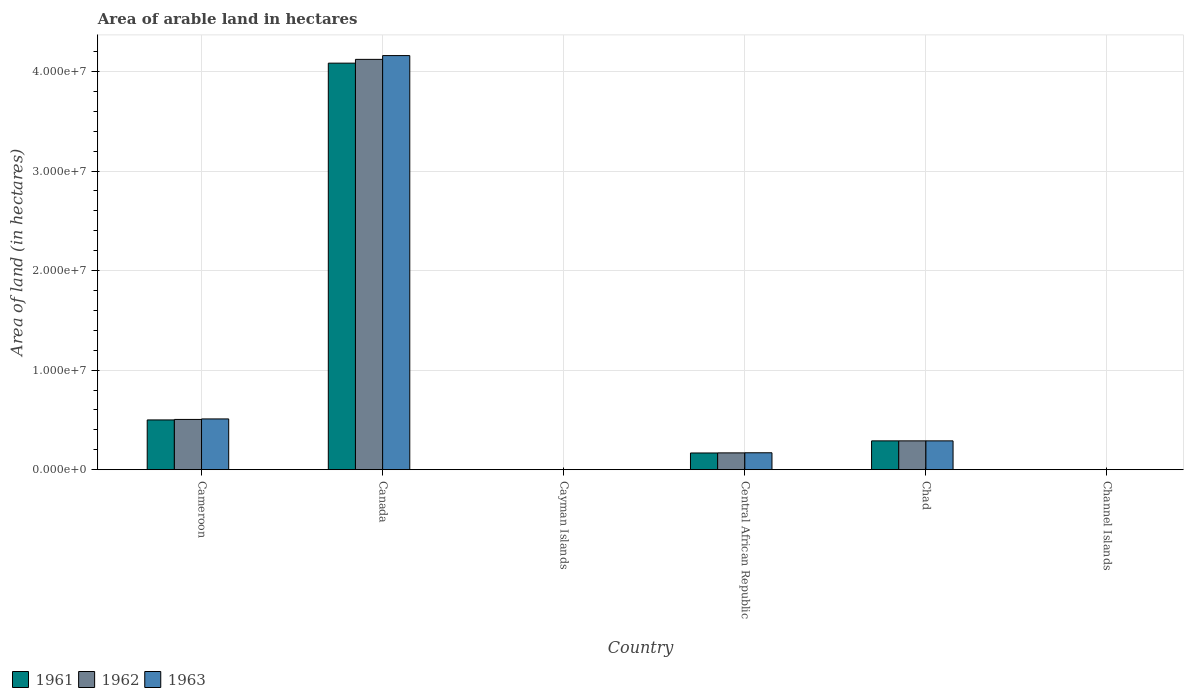How many different coloured bars are there?
Provide a succinct answer. 3. How many bars are there on the 2nd tick from the left?
Offer a terse response. 3. What is the label of the 3rd group of bars from the left?
Keep it short and to the point. Cayman Islands. Across all countries, what is the maximum total arable land in 1961?
Make the answer very short. 4.08e+07. In which country was the total arable land in 1962 minimum?
Make the answer very short. Cayman Islands. What is the total total arable land in 1963 in the graph?
Your response must be concise. 5.13e+07. What is the difference between the total arable land in 1963 in Central African Republic and that in Chad?
Give a very brief answer. -1.20e+06. What is the difference between the total arable land in 1962 in Channel Islands and the total arable land in 1961 in Canada?
Offer a very short reply. -4.08e+07. What is the average total arable land in 1962 per country?
Ensure brevity in your answer.  8.48e+06. In how many countries, is the total arable land in 1963 greater than 18000000 hectares?
Make the answer very short. 1. What is the ratio of the total arable land in 1961 in Cayman Islands to that in Chad?
Provide a succinct answer. 6.903693476009665e-5. Is the total arable land in 1962 in Cameroon less than that in Cayman Islands?
Your response must be concise. No. What is the difference between the highest and the second highest total arable land in 1961?
Ensure brevity in your answer.  3.58e+07. What is the difference between the highest and the lowest total arable land in 1962?
Your answer should be compact. 4.12e+07. In how many countries, is the total arable land in 1963 greater than the average total arable land in 1963 taken over all countries?
Offer a terse response. 1. What does the 2nd bar from the right in Cameroon represents?
Keep it short and to the point. 1962. Is it the case that in every country, the sum of the total arable land in 1962 and total arable land in 1961 is greater than the total arable land in 1963?
Your answer should be very brief. Yes. What is the difference between two consecutive major ticks on the Y-axis?
Provide a succinct answer. 1.00e+07. Are the values on the major ticks of Y-axis written in scientific E-notation?
Keep it short and to the point. Yes. Does the graph contain any zero values?
Make the answer very short. No. Does the graph contain grids?
Provide a succinct answer. Yes. Where does the legend appear in the graph?
Make the answer very short. Bottom left. How many legend labels are there?
Give a very brief answer. 3. What is the title of the graph?
Keep it short and to the point. Area of arable land in hectares. What is the label or title of the X-axis?
Provide a succinct answer. Country. What is the label or title of the Y-axis?
Offer a terse response. Area of land (in hectares). What is the Area of land (in hectares) in 1961 in Cameroon?
Offer a very short reply. 5.00e+06. What is the Area of land (in hectares) of 1962 in Cameroon?
Provide a succinct answer. 5.05e+06. What is the Area of land (in hectares) in 1963 in Cameroon?
Your answer should be compact. 5.10e+06. What is the Area of land (in hectares) in 1961 in Canada?
Your response must be concise. 4.08e+07. What is the Area of land (in hectares) of 1962 in Canada?
Your response must be concise. 4.12e+07. What is the Area of land (in hectares) of 1963 in Canada?
Keep it short and to the point. 4.16e+07. What is the Area of land (in hectares) of 1963 in Cayman Islands?
Your answer should be very brief. 200. What is the Area of land (in hectares) of 1961 in Central African Republic?
Make the answer very short. 1.68e+06. What is the Area of land (in hectares) of 1962 in Central African Republic?
Keep it short and to the point. 1.69e+06. What is the Area of land (in hectares) in 1963 in Central African Republic?
Your answer should be very brief. 1.70e+06. What is the Area of land (in hectares) of 1961 in Chad?
Keep it short and to the point. 2.90e+06. What is the Area of land (in hectares) in 1962 in Chad?
Your answer should be very brief. 2.90e+06. What is the Area of land (in hectares) of 1963 in Chad?
Your answer should be compact. 2.90e+06. What is the Area of land (in hectares) in 1961 in Channel Islands?
Keep it short and to the point. 4000. What is the Area of land (in hectares) in 1962 in Channel Islands?
Your response must be concise. 4000. What is the Area of land (in hectares) of 1963 in Channel Islands?
Your answer should be compact. 4000. Across all countries, what is the maximum Area of land (in hectares) of 1961?
Your answer should be very brief. 4.08e+07. Across all countries, what is the maximum Area of land (in hectares) in 1962?
Your response must be concise. 4.12e+07. Across all countries, what is the maximum Area of land (in hectares) in 1963?
Offer a terse response. 4.16e+07. Across all countries, what is the minimum Area of land (in hectares) of 1961?
Offer a very short reply. 200. Across all countries, what is the minimum Area of land (in hectares) in 1962?
Offer a terse response. 200. What is the total Area of land (in hectares) in 1961 in the graph?
Give a very brief answer. 5.04e+07. What is the total Area of land (in hectares) in 1962 in the graph?
Offer a very short reply. 5.09e+07. What is the total Area of land (in hectares) of 1963 in the graph?
Make the answer very short. 5.13e+07. What is the difference between the Area of land (in hectares) of 1961 in Cameroon and that in Canada?
Offer a terse response. -3.58e+07. What is the difference between the Area of land (in hectares) in 1962 in Cameroon and that in Canada?
Your answer should be very brief. -3.62e+07. What is the difference between the Area of land (in hectares) in 1963 in Cameroon and that in Canada?
Make the answer very short. -3.65e+07. What is the difference between the Area of land (in hectares) of 1961 in Cameroon and that in Cayman Islands?
Make the answer very short. 5.00e+06. What is the difference between the Area of land (in hectares) of 1962 in Cameroon and that in Cayman Islands?
Your answer should be compact. 5.05e+06. What is the difference between the Area of land (in hectares) in 1963 in Cameroon and that in Cayman Islands?
Give a very brief answer. 5.10e+06. What is the difference between the Area of land (in hectares) of 1961 in Cameroon and that in Central African Republic?
Your answer should be compact. 3.32e+06. What is the difference between the Area of land (in hectares) in 1962 in Cameroon and that in Central African Republic?
Your response must be concise. 3.36e+06. What is the difference between the Area of land (in hectares) in 1963 in Cameroon and that in Central African Republic?
Ensure brevity in your answer.  3.40e+06. What is the difference between the Area of land (in hectares) in 1961 in Cameroon and that in Chad?
Make the answer very short. 2.10e+06. What is the difference between the Area of land (in hectares) in 1962 in Cameroon and that in Chad?
Your answer should be compact. 2.15e+06. What is the difference between the Area of land (in hectares) in 1963 in Cameroon and that in Chad?
Your response must be concise. 2.20e+06. What is the difference between the Area of land (in hectares) of 1961 in Cameroon and that in Channel Islands?
Provide a short and direct response. 5.00e+06. What is the difference between the Area of land (in hectares) of 1962 in Cameroon and that in Channel Islands?
Keep it short and to the point. 5.05e+06. What is the difference between the Area of land (in hectares) of 1963 in Cameroon and that in Channel Islands?
Your response must be concise. 5.10e+06. What is the difference between the Area of land (in hectares) in 1961 in Canada and that in Cayman Islands?
Provide a short and direct response. 4.08e+07. What is the difference between the Area of land (in hectares) in 1962 in Canada and that in Cayman Islands?
Your answer should be compact. 4.12e+07. What is the difference between the Area of land (in hectares) in 1963 in Canada and that in Cayman Islands?
Your response must be concise. 4.16e+07. What is the difference between the Area of land (in hectares) in 1961 in Canada and that in Central African Republic?
Provide a succinct answer. 3.92e+07. What is the difference between the Area of land (in hectares) of 1962 in Canada and that in Central African Republic?
Give a very brief answer. 3.95e+07. What is the difference between the Area of land (in hectares) in 1963 in Canada and that in Central African Republic?
Your answer should be very brief. 3.99e+07. What is the difference between the Area of land (in hectares) of 1961 in Canada and that in Chad?
Your answer should be very brief. 3.79e+07. What is the difference between the Area of land (in hectares) of 1962 in Canada and that in Chad?
Your answer should be compact. 3.83e+07. What is the difference between the Area of land (in hectares) in 1963 in Canada and that in Chad?
Provide a short and direct response. 3.87e+07. What is the difference between the Area of land (in hectares) in 1961 in Canada and that in Channel Islands?
Provide a short and direct response. 4.08e+07. What is the difference between the Area of land (in hectares) in 1962 in Canada and that in Channel Islands?
Offer a very short reply. 4.12e+07. What is the difference between the Area of land (in hectares) in 1963 in Canada and that in Channel Islands?
Offer a terse response. 4.16e+07. What is the difference between the Area of land (in hectares) in 1961 in Cayman Islands and that in Central African Republic?
Your response must be concise. -1.68e+06. What is the difference between the Area of land (in hectares) in 1962 in Cayman Islands and that in Central African Republic?
Your answer should be compact. -1.69e+06. What is the difference between the Area of land (in hectares) of 1963 in Cayman Islands and that in Central African Republic?
Your answer should be compact. -1.70e+06. What is the difference between the Area of land (in hectares) in 1961 in Cayman Islands and that in Chad?
Make the answer very short. -2.90e+06. What is the difference between the Area of land (in hectares) in 1962 in Cayman Islands and that in Chad?
Your answer should be compact. -2.90e+06. What is the difference between the Area of land (in hectares) of 1963 in Cayman Islands and that in Chad?
Offer a very short reply. -2.90e+06. What is the difference between the Area of land (in hectares) in 1961 in Cayman Islands and that in Channel Islands?
Your answer should be very brief. -3800. What is the difference between the Area of land (in hectares) of 1962 in Cayman Islands and that in Channel Islands?
Provide a succinct answer. -3800. What is the difference between the Area of land (in hectares) in 1963 in Cayman Islands and that in Channel Islands?
Keep it short and to the point. -3800. What is the difference between the Area of land (in hectares) of 1961 in Central African Republic and that in Chad?
Provide a succinct answer. -1.22e+06. What is the difference between the Area of land (in hectares) of 1962 in Central African Republic and that in Chad?
Offer a terse response. -1.21e+06. What is the difference between the Area of land (in hectares) in 1963 in Central African Republic and that in Chad?
Keep it short and to the point. -1.20e+06. What is the difference between the Area of land (in hectares) of 1961 in Central African Republic and that in Channel Islands?
Your response must be concise. 1.68e+06. What is the difference between the Area of land (in hectares) in 1962 in Central African Republic and that in Channel Islands?
Keep it short and to the point. 1.69e+06. What is the difference between the Area of land (in hectares) of 1963 in Central African Republic and that in Channel Islands?
Your answer should be very brief. 1.70e+06. What is the difference between the Area of land (in hectares) in 1961 in Chad and that in Channel Islands?
Ensure brevity in your answer.  2.89e+06. What is the difference between the Area of land (in hectares) of 1962 in Chad and that in Channel Islands?
Provide a short and direct response. 2.89e+06. What is the difference between the Area of land (in hectares) in 1963 in Chad and that in Channel Islands?
Provide a succinct answer. 2.89e+06. What is the difference between the Area of land (in hectares) in 1961 in Cameroon and the Area of land (in hectares) in 1962 in Canada?
Your answer should be very brief. -3.62e+07. What is the difference between the Area of land (in hectares) in 1961 in Cameroon and the Area of land (in hectares) in 1963 in Canada?
Provide a succinct answer. -3.66e+07. What is the difference between the Area of land (in hectares) in 1962 in Cameroon and the Area of land (in hectares) in 1963 in Canada?
Offer a terse response. -3.66e+07. What is the difference between the Area of land (in hectares) of 1961 in Cameroon and the Area of land (in hectares) of 1962 in Cayman Islands?
Your answer should be very brief. 5.00e+06. What is the difference between the Area of land (in hectares) in 1961 in Cameroon and the Area of land (in hectares) in 1963 in Cayman Islands?
Ensure brevity in your answer.  5.00e+06. What is the difference between the Area of land (in hectares) of 1962 in Cameroon and the Area of land (in hectares) of 1963 in Cayman Islands?
Your response must be concise. 5.05e+06. What is the difference between the Area of land (in hectares) in 1961 in Cameroon and the Area of land (in hectares) in 1962 in Central African Republic?
Offer a terse response. 3.31e+06. What is the difference between the Area of land (in hectares) of 1961 in Cameroon and the Area of land (in hectares) of 1963 in Central African Republic?
Make the answer very short. 3.30e+06. What is the difference between the Area of land (in hectares) in 1962 in Cameroon and the Area of land (in hectares) in 1963 in Central African Republic?
Provide a succinct answer. 3.35e+06. What is the difference between the Area of land (in hectares) in 1961 in Cameroon and the Area of land (in hectares) in 1962 in Chad?
Give a very brief answer. 2.10e+06. What is the difference between the Area of land (in hectares) of 1961 in Cameroon and the Area of land (in hectares) of 1963 in Chad?
Your answer should be compact. 2.10e+06. What is the difference between the Area of land (in hectares) of 1962 in Cameroon and the Area of land (in hectares) of 1963 in Chad?
Your response must be concise. 2.15e+06. What is the difference between the Area of land (in hectares) in 1961 in Cameroon and the Area of land (in hectares) in 1962 in Channel Islands?
Your answer should be very brief. 5.00e+06. What is the difference between the Area of land (in hectares) of 1961 in Cameroon and the Area of land (in hectares) of 1963 in Channel Islands?
Make the answer very short. 5.00e+06. What is the difference between the Area of land (in hectares) in 1962 in Cameroon and the Area of land (in hectares) in 1963 in Channel Islands?
Your answer should be compact. 5.05e+06. What is the difference between the Area of land (in hectares) in 1961 in Canada and the Area of land (in hectares) in 1962 in Cayman Islands?
Offer a terse response. 4.08e+07. What is the difference between the Area of land (in hectares) in 1961 in Canada and the Area of land (in hectares) in 1963 in Cayman Islands?
Provide a succinct answer. 4.08e+07. What is the difference between the Area of land (in hectares) of 1962 in Canada and the Area of land (in hectares) of 1963 in Cayman Islands?
Provide a succinct answer. 4.12e+07. What is the difference between the Area of land (in hectares) in 1961 in Canada and the Area of land (in hectares) in 1962 in Central African Republic?
Give a very brief answer. 3.92e+07. What is the difference between the Area of land (in hectares) in 1961 in Canada and the Area of land (in hectares) in 1963 in Central African Republic?
Give a very brief answer. 3.91e+07. What is the difference between the Area of land (in hectares) of 1962 in Canada and the Area of land (in hectares) of 1963 in Central African Republic?
Offer a very short reply. 3.95e+07. What is the difference between the Area of land (in hectares) in 1961 in Canada and the Area of land (in hectares) in 1962 in Chad?
Offer a terse response. 3.79e+07. What is the difference between the Area of land (in hectares) in 1961 in Canada and the Area of land (in hectares) in 1963 in Chad?
Offer a terse response. 3.79e+07. What is the difference between the Area of land (in hectares) of 1962 in Canada and the Area of land (in hectares) of 1963 in Chad?
Offer a terse response. 3.83e+07. What is the difference between the Area of land (in hectares) of 1961 in Canada and the Area of land (in hectares) of 1962 in Channel Islands?
Provide a succinct answer. 4.08e+07. What is the difference between the Area of land (in hectares) of 1961 in Canada and the Area of land (in hectares) of 1963 in Channel Islands?
Keep it short and to the point. 4.08e+07. What is the difference between the Area of land (in hectares) of 1962 in Canada and the Area of land (in hectares) of 1963 in Channel Islands?
Give a very brief answer. 4.12e+07. What is the difference between the Area of land (in hectares) in 1961 in Cayman Islands and the Area of land (in hectares) in 1962 in Central African Republic?
Make the answer very short. -1.69e+06. What is the difference between the Area of land (in hectares) of 1961 in Cayman Islands and the Area of land (in hectares) of 1963 in Central African Republic?
Offer a terse response. -1.70e+06. What is the difference between the Area of land (in hectares) of 1962 in Cayman Islands and the Area of land (in hectares) of 1963 in Central African Republic?
Ensure brevity in your answer.  -1.70e+06. What is the difference between the Area of land (in hectares) of 1961 in Cayman Islands and the Area of land (in hectares) of 1962 in Chad?
Keep it short and to the point. -2.90e+06. What is the difference between the Area of land (in hectares) of 1961 in Cayman Islands and the Area of land (in hectares) of 1963 in Chad?
Provide a succinct answer. -2.90e+06. What is the difference between the Area of land (in hectares) of 1962 in Cayman Islands and the Area of land (in hectares) of 1963 in Chad?
Your answer should be very brief. -2.90e+06. What is the difference between the Area of land (in hectares) in 1961 in Cayman Islands and the Area of land (in hectares) in 1962 in Channel Islands?
Your answer should be very brief. -3800. What is the difference between the Area of land (in hectares) in 1961 in Cayman Islands and the Area of land (in hectares) in 1963 in Channel Islands?
Ensure brevity in your answer.  -3800. What is the difference between the Area of land (in hectares) of 1962 in Cayman Islands and the Area of land (in hectares) of 1963 in Channel Islands?
Provide a succinct answer. -3800. What is the difference between the Area of land (in hectares) in 1961 in Central African Republic and the Area of land (in hectares) in 1962 in Chad?
Give a very brief answer. -1.22e+06. What is the difference between the Area of land (in hectares) of 1961 in Central African Republic and the Area of land (in hectares) of 1963 in Chad?
Provide a succinct answer. -1.22e+06. What is the difference between the Area of land (in hectares) of 1962 in Central African Republic and the Area of land (in hectares) of 1963 in Chad?
Your answer should be compact. -1.21e+06. What is the difference between the Area of land (in hectares) of 1961 in Central African Republic and the Area of land (in hectares) of 1962 in Channel Islands?
Your response must be concise. 1.68e+06. What is the difference between the Area of land (in hectares) of 1961 in Central African Republic and the Area of land (in hectares) of 1963 in Channel Islands?
Your response must be concise. 1.68e+06. What is the difference between the Area of land (in hectares) of 1962 in Central African Republic and the Area of land (in hectares) of 1963 in Channel Islands?
Your answer should be compact. 1.69e+06. What is the difference between the Area of land (in hectares) of 1961 in Chad and the Area of land (in hectares) of 1962 in Channel Islands?
Provide a short and direct response. 2.89e+06. What is the difference between the Area of land (in hectares) in 1961 in Chad and the Area of land (in hectares) in 1963 in Channel Islands?
Make the answer very short. 2.89e+06. What is the difference between the Area of land (in hectares) of 1962 in Chad and the Area of land (in hectares) of 1963 in Channel Islands?
Give a very brief answer. 2.89e+06. What is the average Area of land (in hectares) in 1961 per country?
Your answer should be very brief. 8.40e+06. What is the average Area of land (in hectares) in 1962 per country?
Your response must be concise. 8.48e+06. What is the average Area of land (in hectares) in 1963 per country?
Give a very brief answer. 8.55e+06. What is the difference between the Area of land (in hectares) of 1961 and Area of land (in hectares) of 1962 in Cameroon?
Provide a short and direct response. -5.00e+04. What is the difference between the Area of land (in hectares) in 1962 and Area of land (in hectares) in 1963 in Cameroon?
Offer a very short reply. -5.00e+04. What is the difference between the Area of land (in hectares) in 1961 and Area of land (in hectares) in 1962 in Canada?
Keep it short and to the point. -3.81e+05. What is the difference between the Area of land (in hectares) of 1961 and Area of land (in hectares) of 1963 in Canada?
Your response must be concise. -7.61e+05. What is the difference between the Area of land (in hectares) in 1962 and Area of land (in hectares) in 1963 in Canada?
Offer a terse response. -3.80e+05. What is the difference between the Area of land (in hectares) in 1961 and Area of land (in hectares) in 1962 in Cayman Islands?
Your answer should be compact. 0. What is the difference between the Area of land (in hectares) in 1962 and Area of land (in hectares) in 1963 in Central African Republic?
Provide a succinct answer. -10000. What is the difference between the Area of land (in hectares) of 1961 and Area of land (in hectares) of 1963 in Chad?
Give a very brief answer. 0. What is the difference between the Area of land (in hectares) of 1961 and Area of land (in hectares) of 1963 in Channel Islands?
Ensure brevity in your answer.  0. What is the ratio of the Area of land (in hectares) in 1961 in Cameroon to that in Canada?
Your response must be concise. 0.12. What is the ratio of the Area of land (in hectares) in 1962 in Cameroon to that in Canada?
Make the answer very short. 0.12. What is the ratio of the Area of land (in hectares) in 1963 in Cameroon to that in Canada?
Offer a very short reply. 0.12. What is the ratio of the Area of land (in hectares) of 1961 in Cameroon to that in Cayman Islands?
Keep it short and to the point. 2.50e+04. What is the ratio of the Area of land (in hectares) of 1962 in Cameroon to that in Cayman Islands?
Ensure brevity in your answer.  2.52e+04. What is the ratio of the Area of land (in hectares) in 1963 in Cameroon to that in Cayman Islands?
Your response must be concise. 2.55e+04. What is the ratio of the Area of land (in hectares) in 1961 in Cameroon to that in Central African Republic?
Keep it short and to the point. 2.98. What is the ratio of the Area of land (in hectares) of 1962 in Cameroon to that in Central African Republic?
Your response must be concise. 2.99. What is the ratio of the Area of land (in hectares) in 1961 in Cameroon to that in Chad?
Ensure brevity in your answer.  1.73. What is the ratio of the Area of land (in hectares) in 1962 in Cameroon to that in Chad?
Ensure brevity in your answer.  1.74. What is the ratio of the Area of land (in hectares) in 1963 in Cameroon to that in Chad?
Your response must be concise. 1.76. What is the ratio of the Area of land (in hectares) in 1961 in Cameroon to that in Channel Islands?
Your answer should be compact. 1250. What is the ratio of the Area of land (in hectares) of 1962 in Cameroon to that in Channel Islands?
Your answer should be compact. 1262.5. What is the ratio of the Area of land (in hectares) in 1963 in Cameroon to that in Channel Islands?
Offer a very short reply. 1275. What is the ratio of the Area of land (in hectares) of 1961 in Canada to that in Cayman Islands?
Your answer should be very brief. 2.04e+05. What is the ratio of the Area of land (in hectares) of 1962 in Canada to that in Cayman Islands?
Make the answer very short. 2.06e+05. What is the ratio of the Area of land (in hectares) in 1963 in Canada to that in Cayman Islands?
Offer a terse response. 2.08e+05. What is the ratio of the Area of land (in hectares) of 1961 in Canada to that in Central African Republic?
Offer a terse response. 24.31. What is the ratio of the Area of land (in hectares) in 1962 in Canada to that in Central African Republic?
Your response must be concise. 24.39. What is the ratio of the Area of land (in hectares) in 1963 in Canada to that in Central African Republic?
Ensure brevity in your answer.  24.47. What is the ratio of the Area of land (in hectares) of 1961 in Canada to that in Chad?
Keep it short and to the point. 14.1. What is the ratio of the Area of land (in hectares) in 1962 in Canada to that in Chad?
Offer a terse response. 14.23. What is the ratio of the Area of land (in hectares) of 1963 in Canada to that in Chad?
Your answer should be very brief. 14.36. What is the ratio of the Area of land (in hectares) in 1961 in Canada to that in Channel Islands?
Offer a terse response. 1.02e+04. What is the ratio of the Area of land (in hectares) of 1962 in Canada to that in Channel Islands?
Ensure brevity in your answer.  1.03e+04. What is the ratio of the Area of land (in hectares) in 1963 in Canada to that in Channel Islands?
Your answer should be very brief. 1.04e+04. What is the ratio of the Area of land (in hectares) of 1961 in Cayman Islands to that in Central African Republic?
Make the answer very short. 0. What is the ratio of the Area of land (in hectares) of 1963 in Cayman Islands to that in Central African Republic?
Provide a succinct answer. 0. What is the ratio of the Area of land (in hectares) of 1962 in Cayman Islands to that in Channel Islands?
Provide a short and direct response. 0.05. What is the ratio of the Area of land (in hectares) of 1961 in Central African Republic to that in Chad?
Provide a short and direct response. 0.58. What is the ratio of the Area of land (in hectares) of 1962 in Central African Republic to that in Chad?
Make the answer very short. 0.58. What is the ratio of the Area of land (in hectares) in 1963 in Central African Republic to that in Chad?
Give a very brief answer. 0.59. What is the ratio of the Area of land (in hectares) in 1961 in Central African Republic to that in Channel Islands?
Give a very brief answer. 420. What is the ratio of the Area of land (in hectares) of 1962 in Central African Republic to that in Channel Islands?
Your answer should be very brief. 422.5. What is the ratio of the Area of land (in hectares) of 1963 in Central African Republic to that in Channel Islands?
Provide a succinct answer. 425. What is the ratio of the Area of land (in hectares) of 1961 in Chad to that in Channel Islands?
Provide a short and direct response. 724.25. What is the ratio of the Area of land (in hectares) of 1962 in Chad to that in Channel Islands?
Provide a succinct answer. 724.25. What is the ratio of the Area of land (in hectares) of 1963 in Chad to that in Channel Islands?
Provide a succinct answer. 724.25. What is the difference between the highest and the second highest Area of land (in hectares) in 1961?
Your answer should be very brief. 3.58e+07. What is the difference between the highest and the second highest Area of land (in hectares) in 1962?
Make the answer very short. 3.62e+07. What is the difference between the highest and the second highest Area of land (in hectares) in 1963?
Keep it short and to the point. 3.65e+07. What is the difference between the highest and the lowest Area of land (in hectares) of 1961?
Make the answer very short. 4.08e+07. What is the difference between the highest and the lowest Area of land (in hectares) of 1962?
Provide a short and direct response. 4.12e+07. What is the difference between the highest and the lowest Area of land (in hectares) in 1963?
Your answer should be compact. 4.16e+07. 